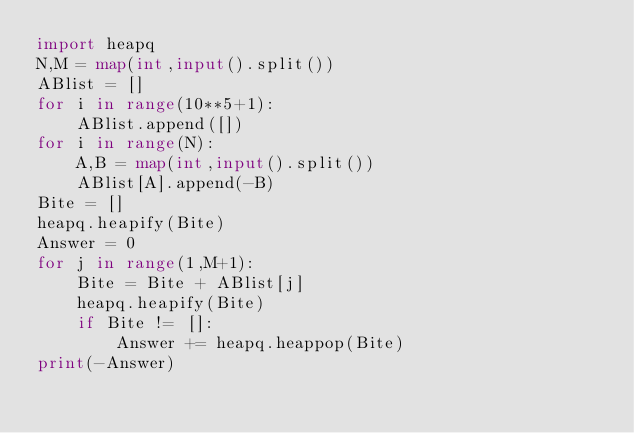<code> <loc_0><loc_0><loc_500><loc_500><_Python_>import heapq
N,M = map(int,input().split())
ABlist = []
for i in range(10**5+1):
    ABlist.append([])
for i in range(N):
    A,B = map(int,input().split())
    ABlist[A].append(-B)
Bite = []
heapq.heapify(Bite)
Answer = 0
for j in range(1,M+1):
    Bite = Bite + ABlist[j]
    heapq.heapify(Bite)
    if Bite != []:
        Answer += heapq.heappop(Bite)
print(-Answer)</code> 